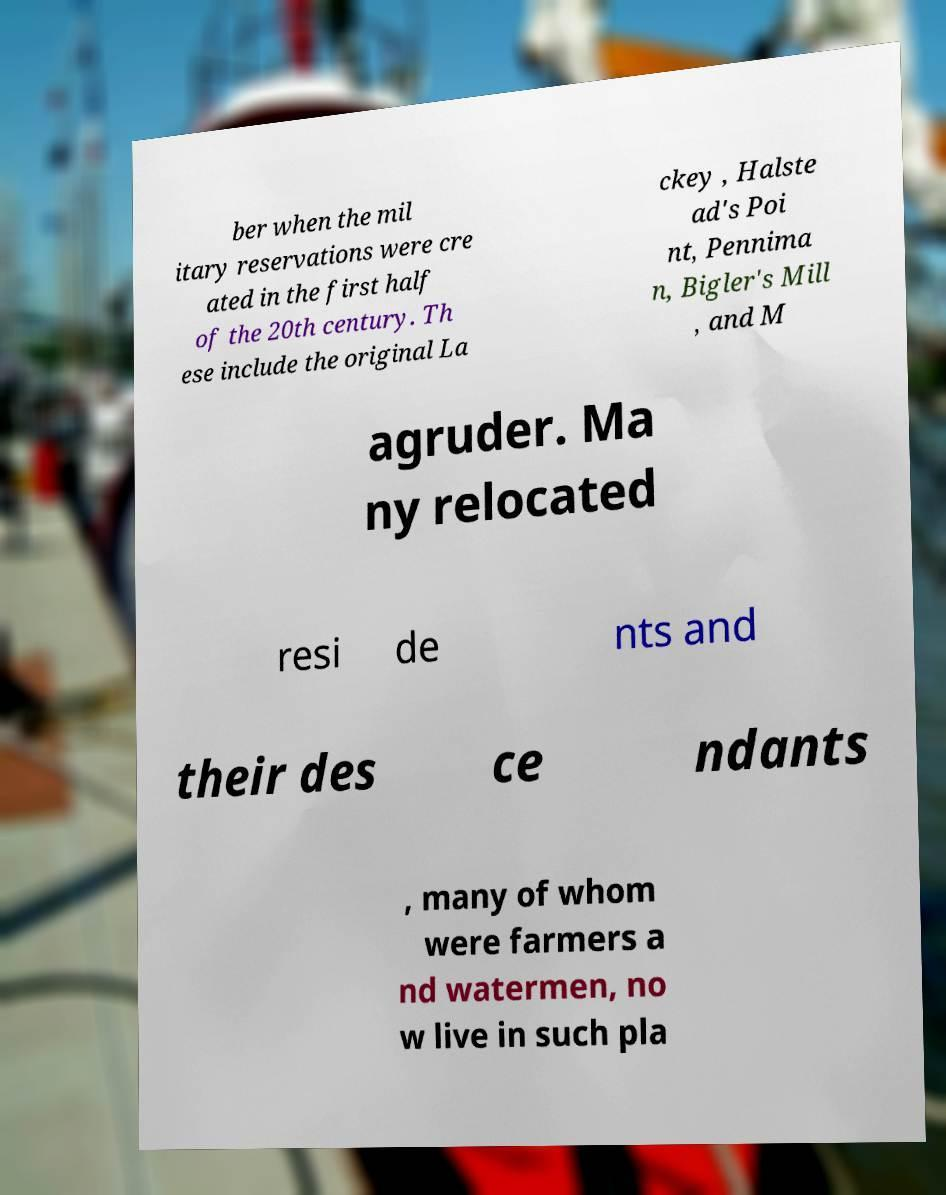For documentation purposes, I need the text within this image transcribed. Could you provide that? ber when the mil itary reservations were cre ated in the first half of the 20th century. Th ese include the original La ckey , Halste ad's Poi nt, Pennima n, Bigler's Mill , and M agruder. Ma ny relocated resi de nts and their des ce ndants , many of whom were farmers a nd watermen, no w live in such pla 